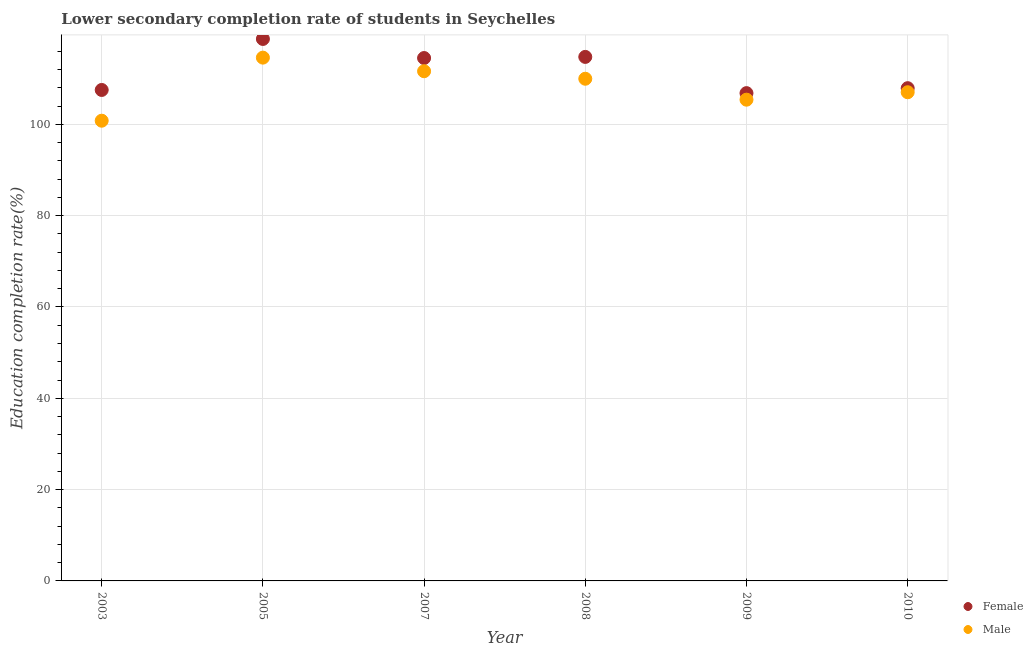How many different coloured dotlines are there?
Make the answer very short. 2. What is the education completion rate of female students in 2010?
Your answer should be very brief. 107.91. Across all years, what is the maximum education completion rate of male students?
Offer a very short reply. 114.6. Across all years, what is the minimum education completion rate of female students?
Your answer should be very brief. 106.82. In which year was the education completion rate of female students minimum?
Your response must be concise. 2009. What is the total education completion rate of female students in the graph?
Make the answer very short. 670.2. What is the difference between the education completion rate of female students in 2005 and that in 2007?
Your response must be concise. 4.18. What is the difference between the education completion rate of male students in 2007 and the education completion rate of female students in 2008?
Provide a succinct answer. -3.13. What is the average education completion rate of male students per year?
Keep it short and to the point. 108.23. In the year 2010, what is the difference between the education completion rate of male students and education completion rate of female students?
Provide a short and direct response. -0.89. In how many years, is the education completion rate of female students greater than 36 %?
Offer a very short reply. 6. What is the ratio of the education completion rate of female students in 2008 to that in 2010?
Your answer should be compact. 1.06. Is the education completion rate of female students in 2007 less than that in 2009?
Provide a short and direct response. No. What is the difference between the highest and the second highest education completion rate of male students?
Offer a terse response. 2.98. What is the difference between the highest and the lowest education completion rate of female students?
Provide a short and direct response. 11.86. In how many years, is the education completion rate of male students greater than the average education completion rate of male students taken over all years?
Give a very brief answer. 3. How many dotlines are there?
Make the answer very short. 2. What is the difference between two consecutive major ticks on the Y-axis?
Your response must be concise. 20. Are the values on the major ticks of Y-axis written in scientific E-notation?
Keep it short and to the point. No. Where does the legend appear in the graph?
Your answer should be very brief. Bottom right. How are the legend labels stacked?
Make the answer very short. Vertical. What is the title of the graph?
Offer a terse response. Lower secondary completion rate of students in Seychelles. Does "Urban" appear as one of the legend labels in the graph?
Provide a succinct answer. No. What is the label or title of the X-axis?
Offer a terse response. Year. What is the label or title of the Y-axis?
Give a very brief answer. Education completion rate(%). What is the Education completion rate(%) of Female in 2003?
Keep it short and to the point. 107.52. What is the Education completion rate(%) in Male in 2003?
Ensure brevity in your answer.  100.78. What is the Education completion rate(%) of Female in 2005?
Your answer should be very brief. 118.69. What is the Education completion rate(%) of Male in 2005?
Keep it short and to the point. 114.6. What is the Education completion rate(%) in Female in 2007?
Make the answer very short. 114.51. What is the Education completion rate(%) in Male in 2007?
Give a very brief answer. 111.62. What is the Education completion rate(%) of Female in 2008?
Your response must be concise. 114.76. What is the Education completion rate(%) of Male in 2008?
Make the answer very short. 109.97. What is the Education completion rate(%) of Female in 2009?
Make the answer very short. 106.82. What is the Education completion rate(%) of Male in 2009?
Make the answer very short. 105.39. What is the Education completion rate(%) of Female in 2010?
Give a very brief answer. 107.91. What is the Education completion rate(%) of Male in 2010?
Offer a terse response. 107.02. Across all years, what is the maximum Education completion rate(%) of Female?
Keep it short and to the point. 118.69. Across all years, what is the maximum Education completion rate(%) in Male?
Make the answer very short. 114.6. Across all years, what is the minimum Education completion rate(%) of Female?
Make the answer very short. 106.82. Across all years, what is the minimum Education completion rate(%) in Male?
Offer a very short reply. 100.78. What is the total Education completion rate(%) in Female in the graph?
Offer a very short reply. 670.2. What is the total Education completion rate(%) in Male in the graph?
Offer a terse response. 649.38. What is the difference between the Education completion rate(%) of Female in 2003 and that in 2005?
Give a very brief answer. -11.17. What is the difference between the Education completion rate(%) of Male in 2003 and that in 2005?
Offer a very short reply. -13.81. What is the difference between the Education completion rate(%) in Female in 2003 and that in 2007?
Provide a short and direct response. -6.99. What is the difference between the Education completion rate(%) in Male in 2003 and that in 2007?
Offer a very short reply. -10.84. What is the difference between the Education completion rate(%) of Female in 2003 and that in 2008?
Provide a succinct answer. -7.24. What is the difference between the Education completion rate(%) in Male in 2003 and that in 2008?
Provide a succinct answer. -9.19. What is the difference between the Education completion rate(%) in Female in 2003 and that in 2009?
Your answer should be compact. 0.7. What is the difference between the Education completion rate(%) of Male in 2003 and that in 2009?
Offer a terse response. -4.61. What is the difference between the Education completion rate(%) in Female in 2003 and that in 2010?
Provide a short and direct response. -0.39. What is the difference between the Education completion rate(%) in Male in 2003 and that in 2010?
Give a very brief answer. -6.23. What is the difference between the Education completion rate(%) of Female in 2005 and that in 2007?
Keep it short and to the point. 4.18. What is the difference between the Education completion rate(%) in Male in 2005 and that in 2007?
Make the answer very short. 2.98. What is the difference between the Education completion rate(%) in Female in 2005 and that in 2008?
Make the answer very short. 3.93. What is the difference between the Education completion rate(%) of Male in 2005 and that in 2008?
Ensure brevity in your answer.  4.62. What is the difference between the Education completion rate(%) of Female in 2005 and that in 2009?
Offer a terse response. 11.86. What is the difference between the Education completion rate(%) of Male in 2005 and that in 2009?
Offer a terse response. 9.21. What is the difference between the Education completion rate(%) of Female in 2005 and that in 2010?
Make the answer very short. 10.78. What is the difference between the Education completion rate(%) of Male in 2005 and that in 2010?
Keep it short and to the point. 7.58. What is the difference between the Education completion rate(%) in Female in 2007 and that in 2008?
Offer a very short reply. -0.25. What is the difference between the Education completion rate(%) of Male in 2007 and that in 2008?
Provide a short and direct response. 1.65. What is the difference between the Education completion rate(%) of Female in 2007 and that in 2009?
Make the answer very short. 7.69. What is the difference between the Education completion rate(%) in Male in 2007 and that in 2009?
Your answer should be very brief. 6.23. What is the difference between the Education completion rate(%) of Female in 2007 and that in 2010?
Ensure brevity in your answer.  6.6. What is the difference between the Education completion rate(%) of Male in 2007 and that in 2010?
Offer a terse response. 4.6. What is the difference between the Education completion rate(%) in Female in 2008 and that in 2009?
Make the answer very short. 7.93. What is the difference between the Education completion rate(%) in Male in 2008 and that in 2009?
Provide a short and direct response. 4.58. What is the difference between the Education completion rate(%) in Female in 2008 and that in 2010?
Your answer should be compact. 6.85. What is the difference between the Education completion rate(%) in Male in 2008 and that in 2010?
Your response must be concise. 2.96. What is the difference between the Education completion rate(%) of Female in 2009 and that in 2010?
Provide a short and direct response. -1.08. What is the difference between the Education completion rate(%) of Male in 2009 and that in 2010?
Your response must be concise. -1.63. What is the difference between the Education completion rate(%) of Female in 2003 and the Education completion rate(%) of Male in 2005?
Your answer should be very brief. -7.08. What is the difference between the Education completion rate(%) of Female in 2003 and the Education completion rate(%) of Male in 2007?
Your answer should be compact. -4.1. What is the difference between the Education completion rate(%) in Female in 2003 and the Education completion rate(%) in Male in 2008?
Offer a terse response. -2.46. What is the difference between the Education completion rate(%) in Female in 2003 and the Education completion rate(%) in Male in 2009?
Provide a short and direct response. 2.13. What is the difference between the Education completion rate(%) in Female in 2003 and the Education completion rate(%) in Male in 2010?
Make the answer very short. 0.5. What is the difference between the Education completion rate(%) in Female in 2005 and the Education completion rate(%) in Male in 2007?
Your answer should be very brief. 7.06. What is the difference between the Education completion rate(%) in Female in 2005 and the Education completion rate(%) in Male in 2008?
Your answer should be very brief. 8.71. What is the difference between the Education completion rate(%) in Female in 2005 and the Education completion rate(%) in Male in 2009?
Your response must be concise. 13.3. What is the difference between the Education completion rate(%) in Female in 2005 and the Education completion rate(%) in Male in 2010?
Provide a short and direct response. 11.67. What is the difference between the Education completion rate(%) of Female in 2007 and the Education completion rate(%) of Male in 2008?
Keep it short and to the point. 4.54. What is the difference between the Education completion rate(%) of Female in 2007 and the Education completion rate(%) of Male in 2009?
Your answer should be very brief. 9.12. What is the difference between the Education completion rate(%) of Female in 2007 and the Education completion rate(%) of Male in 2010?
Provide a succinct answer. 7.49. What is the difference between the Education completion rate(%) of Female in 2008 and the Education completion rate(%) of Male in 2009?
Your response must be concise. 9.37. What is the difference between the Education completion rate(%) in Female in 2008 and the Education completion rate(%) in Male in 2010?
Give a very brief answer. 7.74. What is the difference between the Education completion rate(%) of Female in 2009 and the Education completion rate(%) of Male in 2010?
Ensure brevity in your answer.  -0.2. What is the average Education completion rate(%) in Female per year?
Offer a very short reply. 111.7. What is the average Education completion rate(%) of Male per year?
Your response must be concise. 108.23. In the year 2003, what is the difference between the Education completion rate(%) of Female and Education completion rate(%) of Male?
Your answer should be very brief. 6.73. In the year 2005, what is the difference between the Education completion rate(%) in Female and Education completion rate(%) in Male?
Provide a succinct answer. 4.09. In the year 2007, what is the difference between the Education completion rate(%) in Female and Education completion rate(%) in Male?
Ensure brevity in your answer.  2.89. In the year 2008, what is the difference between the Education completion rate(%) of Female and Education completion rate(%) of Male?
Give a very brief answer. 4.78. In the year 2009, what is the difference between the Education completion rate(%) in Female and Education completion rate(%) in Male?
Provide a short and direct response. 1.43. In the year 2010, what is the difference between the Education completion rate(%) in Female and Education completion rate(%) in Male?
Your response must be concise. 0.89. What is the ratio of the Education completion rate(%) in Female in 2003 to that in 2005?
Keep it short and to the point. 0.91. What is the ratio of the Education completion rate(%) in Male in 2003 to that in 2005?
Make the answer very short. 0.88. What is the ratio of the Education completion rate(%) in Female in 2003 to that in 2007?
Make the answer very short. 0.94. What is the ratio of the Education completion rate(%) in Male in 2003 to that in 2007?
Provide a short and direct response. 0.9. What is the ratio of the Education completion rate(%) in Female in 2003 to that in 2008?
Provide a succinct answer. 0.94. What is the ratio of the Education completion rate(%) of Male in 2003 to that in 2008?
Ensure brevity in your answer.  0.92. What is the ratio of the Education completion rate(%) in Male in 2003 to that in 2009?
Provide a short and direct response. 0.96. What is the ratio of the Education completion rate(%) of Female in 2003 to that in 2010?
Make the answer very short. 1. What is the ratio of the Education completion rate(%) of Male in 2003 to that in 2010?
Make the answer very short. 0.94. What is the ratio of the Education completion rate(%) in Female in 2005 to that in 2007?
Offer a very short reply. 1.04. What is the ratio of the Education completion rate(%) of Male in 2005 to that in 2007?
Your answer should be very brief. 1.03. What is the ratio of the Education completion rate(%) of Female in 2005 to that in 2008?
Provide a short and direct response. 1.03. What is the ratio of the Education completion rate(%) of Male in 2005 to that in 2008?
Keep it short and to the point. 1.04. What is the ratio of the Education completion rate(%) of Female in 2005 to that in 2009?
Offer a very short reply. 1.11. What is the ratio of the Education completion rate(%) in Male in 2005 to that in 2009?
Your answer should be compact. 1.09. What is the ratio of the Education completion rate(%) in Female in 2005 to that in 2010?
Your answer should be very brief. 1.1. What is the ratio of the Education completion rate(%) in Male in 2005 to that in 2010?
Offer a very short reply. 1.07. What is the ratio of the Education completion rate(%) in Female in 2007 to that in 2008?
Make the answer very short. 1. What is the ratio of the Education completion rate(%) in Male in 2007 to that in 2008?
Ensure brevity in your answer.  1.01. What is the ratio of the Education completion rate(%) in Female in 2007 to that in 2009?
Your answer should be compact. 1.07. What is the ratio of the Education completion rate(%) in Male in 2007 to that in 2009?
Make the answer very short. 1.06. What is the ratio of the Education completion rate(%) of Female in 2007 to that in 2010?
Your answer should be compact. 1.06. What is the ratio of the Education completion rate(%) in Male in 2007 to that in 2010?
Provide a succinct answer. 1.04. What is the ratio of the Education completion rate(%) of Female in 2008 to that in 2009?
Ensure brevity in your answer.  1.07. What is the ratio of the Education completion rate(%) of Male in 2008 to that in 2009?
Your answer should be very brief. 1.04. What is the ratio of the Education completion rate(%) of Female in 2008 to that in 2010?
Keep it short and to the point. 1.06. What is the ratio of the Education completion rate(%) of Male in 2008 to that in 2010?
Make the answer very short. 1.03. What is the ratio of the Education completion rate(%) in Female in 2009 to that in 2010?
Your answer should be very brief. 0.99. What is the ratio of the Education completion rate(%) in Male in 2009 to that in 2010?
Give a very brief answer. 0.98. What is the difference between the highest and the second highest Education completion rate(%) in Female?
Make the answer very short. 3.93. What is the difference between the highest and the second highest Education completion rate(%) in Male?
Give a very brief answer. 2.98. What is the difference between the highest and the lowest Education completion rate(%) in Female?
Offer a terse response. 11.86. What is the difference between the highest and the lowest Education completion rate(%) of Male?
Give a very brief answer. 13.81. 